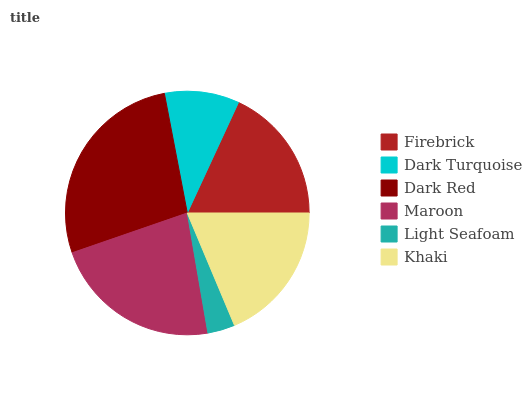Is Light Seafoam the minimum?
Answer yes or no. Yes. Is Dark Red the maximum?
Answer yes or no. Yes. Is Dark Turquoise the minimum?
Answer yes or no. No. Is Dark Turquoise the maximum?
Answer yes or no. No. Is Firebrick greater than Dark Turquoise?
Answer yes or no. Yes. Is Dark Turquoise less than Firebrick?
Answer yes or no. Yes. Is Dark Turquoise greater than Firebrick?
Answer yes or no. No. Is Firebrick less than Dark Turquoise?
Answer yes or no. No. Is Khaki the high median?
Answer yes or no. Yes. Is Firebrick the low median?
Answer yes or no. Yes. Is Light Seafoam the high median?
Answer yes or no. No. Is Khaki the low median?
Answer yes or no. No. 